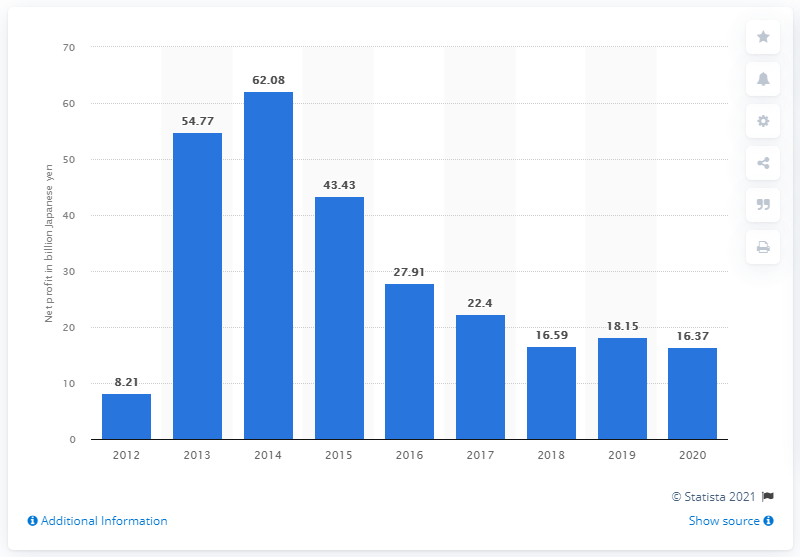Give some essential details in this illustration. GungHo Online Entertainment's net profit in 2020 was 16.37. 